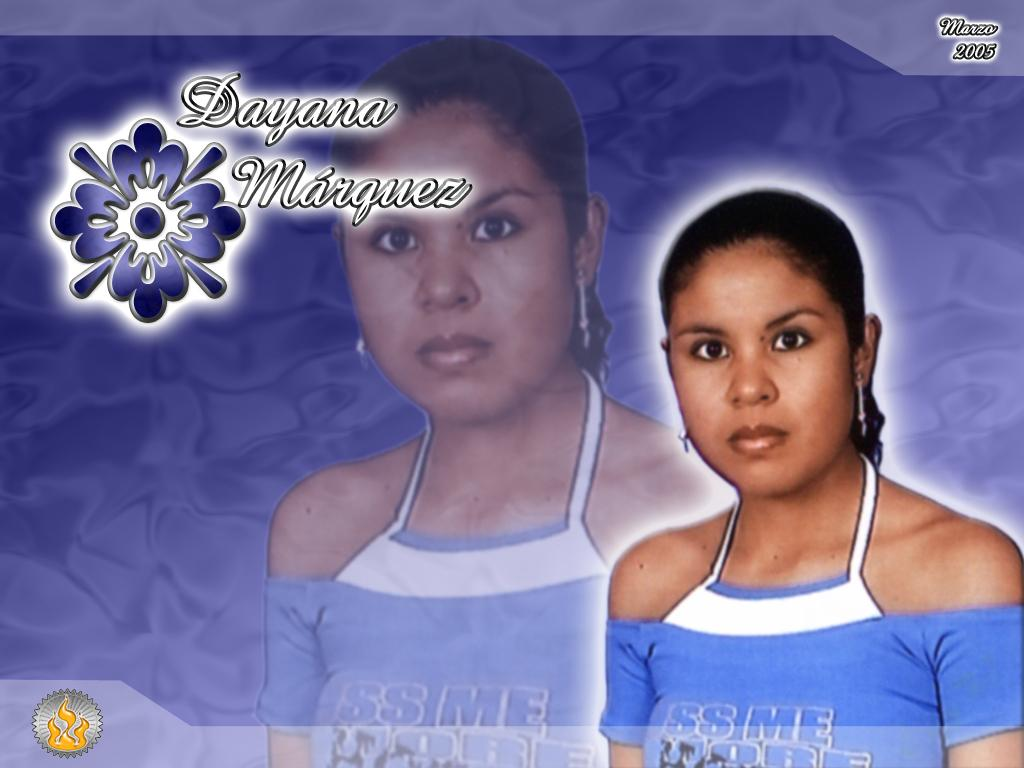<image>
Give a short and clear explanation of the subsequent image. Dayana seems like she is a popular person in a foreign country. 